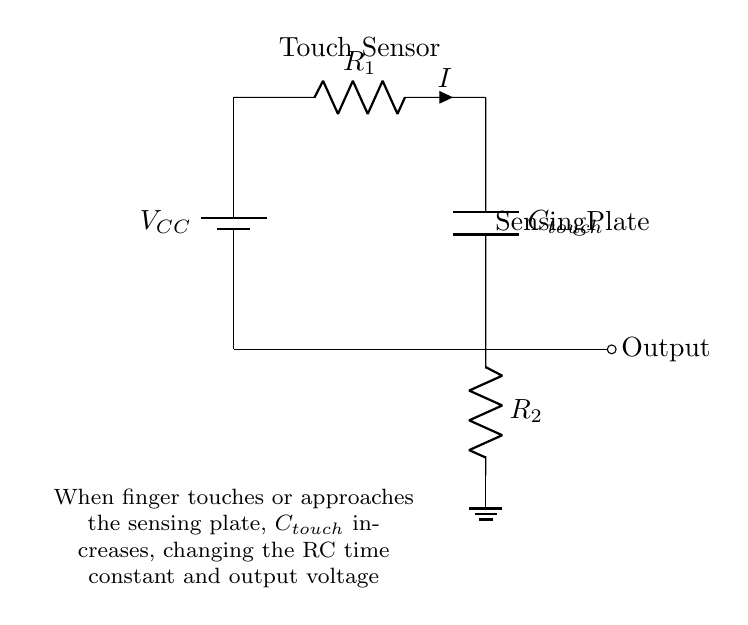What is the supply voltage of this circuit? The supply voltage, labeled as V_CC, is shown near the top left of the circuit. In typical examples, it is commonly assumed to be 5V unless stated otherwise.
Answer: 5V What component acts as the touch sensor in this circuit? The component labeled as C_touch is a capacitor that detects touch. Its capacitance changes when a finger touches or approaches the sensing plate, allowing the circuit to sense the user's input.
Answer: Capacitor What does R_1 represent in this circuit? R_1 is a resistor in the circuit, and it is likely used to limit current and influence the time constant of the RC circuit along with C_touch.
Answer: Resistor How many resistors are present in this circuit? By counting the components labeled as resistors in the diagram (R_1 and R_2), we identify that there are two resistors present in the circuit.
Answer: Two What is the role of C_touch in the operation of this circuit? C_touch functions as a capacitive touch sensor. When a finger approaches or touches the sensing plate, it alters the capacitance and the RC time constant, impacting the output voltage produced by the circuit.
Answer: Touch sensor What happens to the output when the finger touches the sensing plate? When the finger touches the sensing plate, the capacitance C_touch increases, which changes the RC time constant and results in a different output voltage. This voltage change can then indicate a 'touch' event to trigger smart home controls.
Answer: Output changes What type of circuit is represented by this diagram? This diagram represents a capacitive touch sensor circuit designed for use in low power appliances, specifically for smart home controls. It is structured to operate at low voltages and currents typical of such applications.
Answer: Capacitive touch sensor 